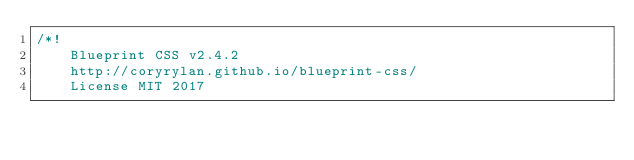<code> <loc_0><loc_0><loc_500><loc_500><_CSS_>/*!
    Blueprint CSS v2.4.2
    http://coryrylan.github.io/blueprint-css/
    License MIT 2017</code> 